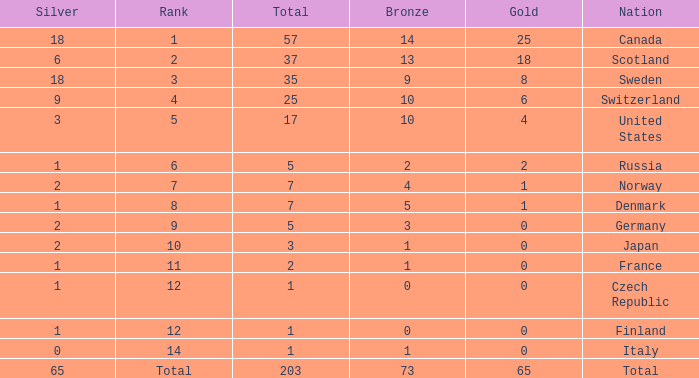What is the number of bronze medals when the total is greater than 1, more than 2 silver medals are won, and the rank is 2? 13.0. 